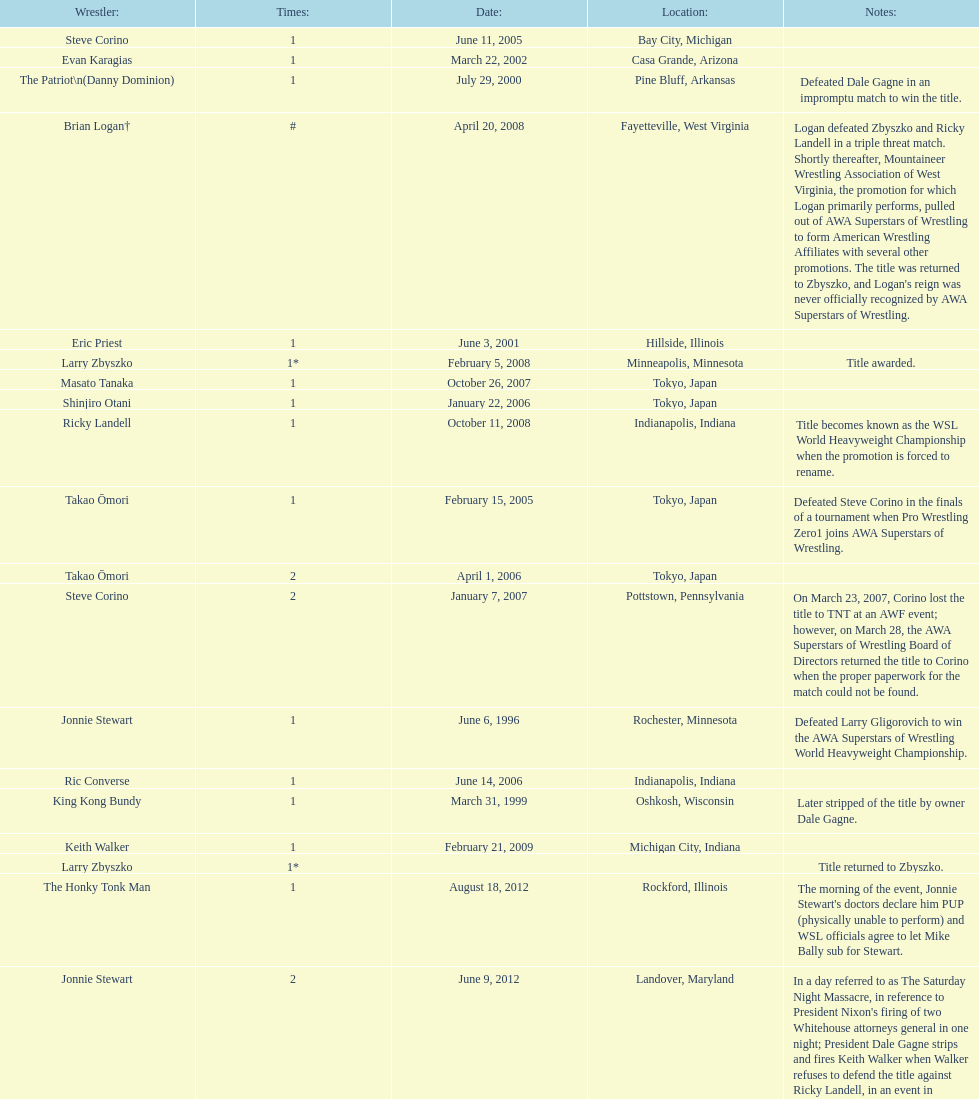When did steve corino win his first wsl title? June 11, 2005. 